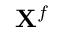<formula> <loc_0><loc_0><loc_500><loc_500>X ^ { f }</formula> 